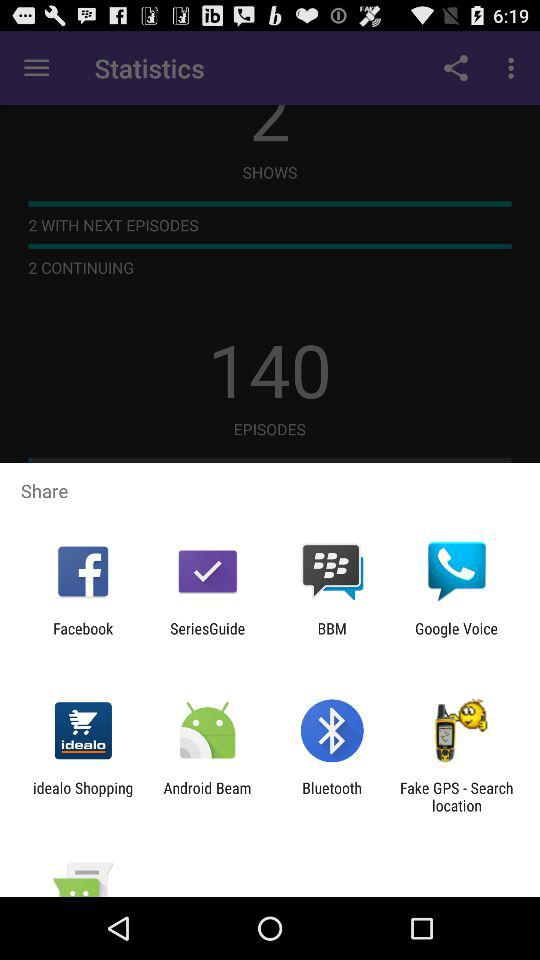How many total episodes are shown? The total episodes are 140. 